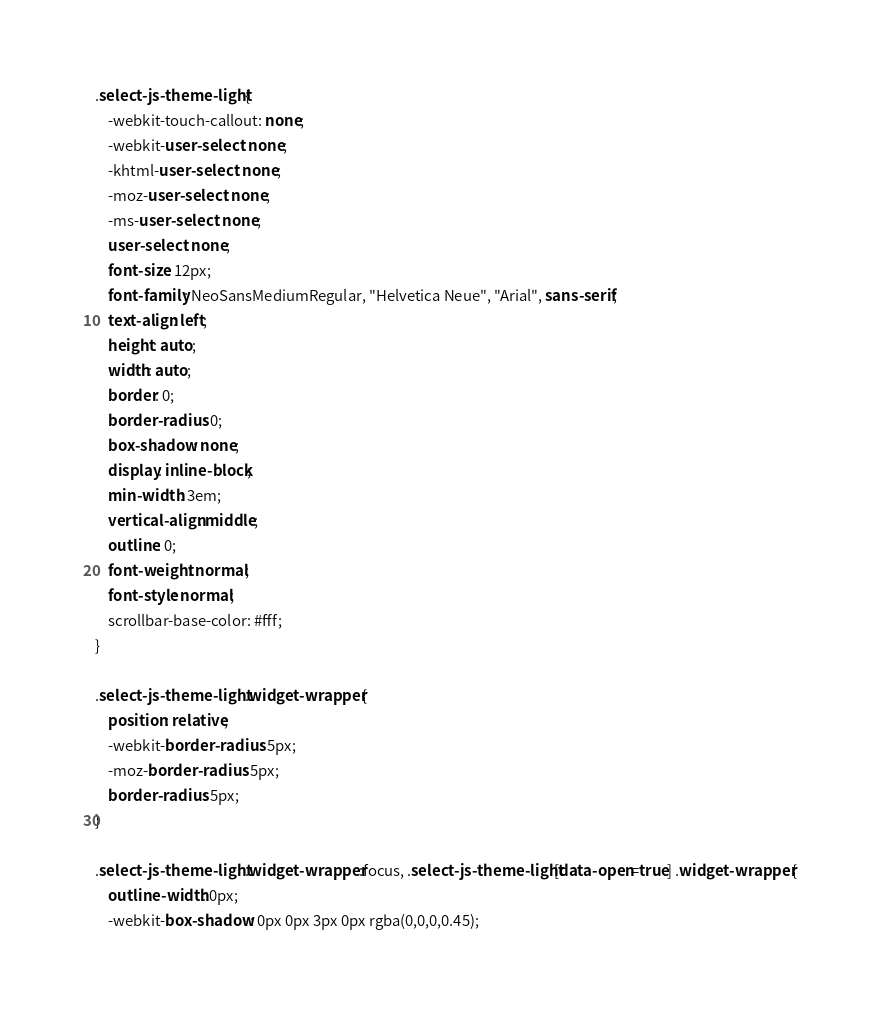Convert code to text. <code><loc_0><loc_0><loc_500><loc_500><_CSS_>.select-js-theme-light {
	-webkit-touch-callout: none; 
	-webkit-user-select: none; 
	-khtml-user-select: none; 
	-moz-user-select: none; 
	-ms-user-select: none; 
	user-select: none; 
	font-size: 12px;
	font-family: NeoSansMediumRegular, "Helvetica Neue", "Arial", sans-serif;
	text-align: left;
	height: auto;
	width: auto;
	border: 0;
	border-radius: 0;
	box-shadow: none;
	display: inline-block;
	min-width: 3em;
    vertical-align: middle;
	outline: 0;
	font-weight: normal;
	font-style: normal;
	scrollbar-base-color: #fff;
}

.select-js-theme-light .widget-wrapper {
	position: relative;
	-webkit-border-radius: 5px;
	-moz-border-radius: 5px;
	border-radius: 5px;
}

.select-js-theme-light .widget-wrapper:focus, .select-js-theme-light[data-open=true] .widget-wrapper {
	outline-width: 0px;
	-webkit-box-shadow: 0px 0px 3px 0px rgba(0,0,0,0.45);</code> 